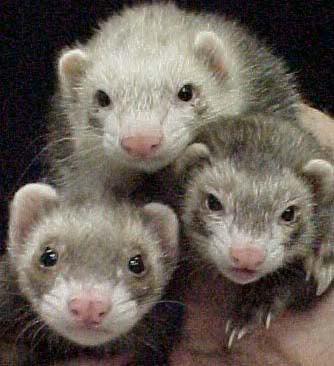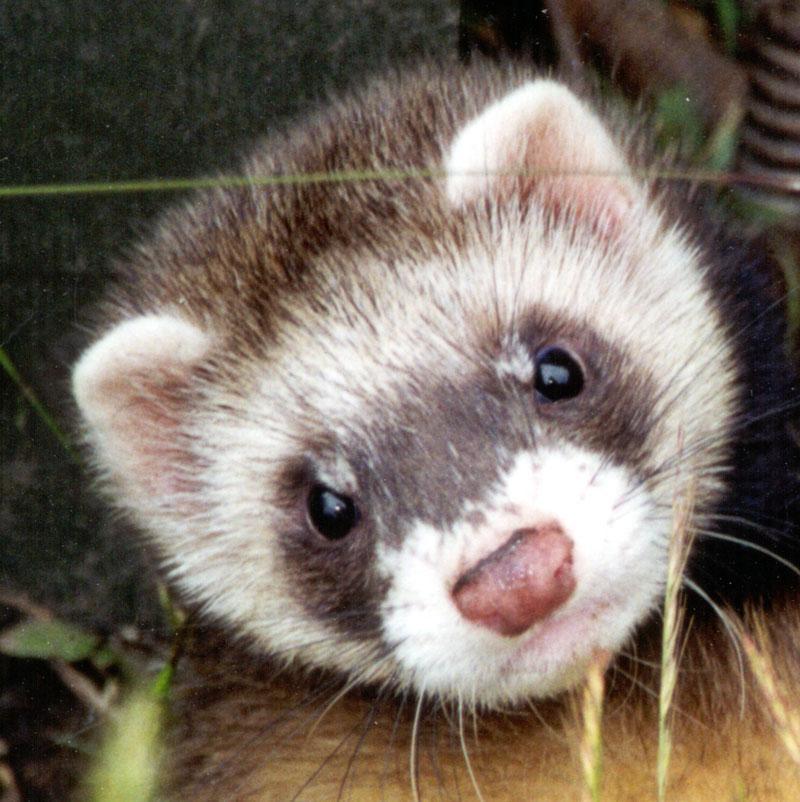The first image is the image on the left, the second image is the image on the right. Given the left and right images, does the statement "The right image depicts more ferrets than the left image." hold true? Answer yes or no. No. 